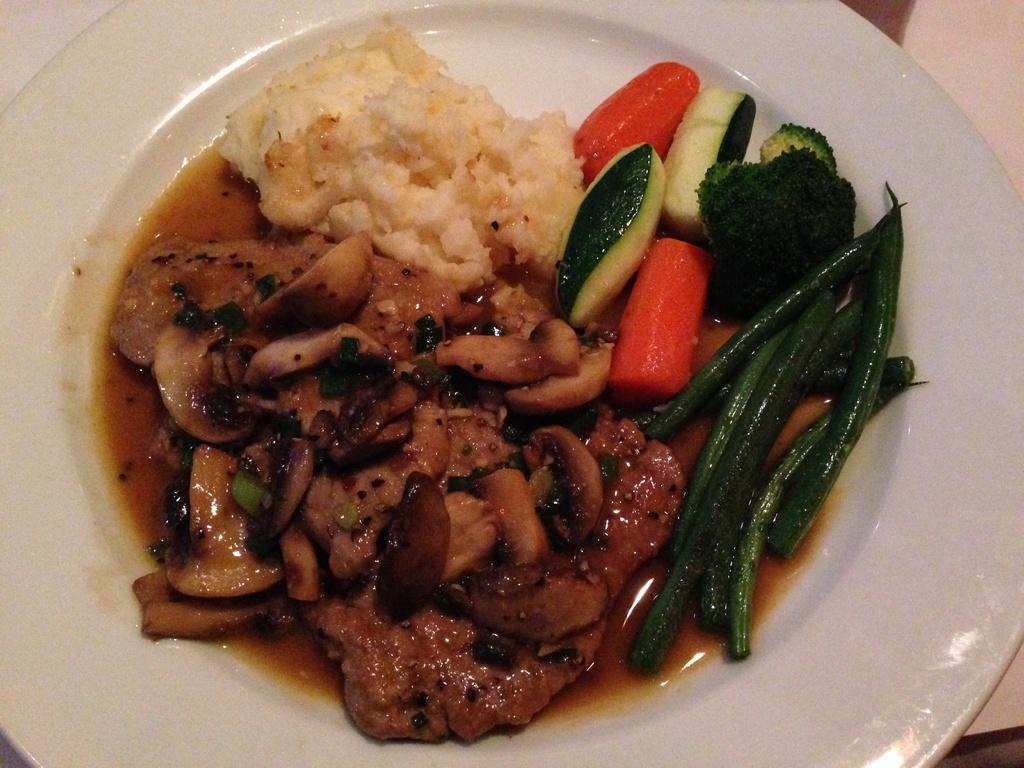What vegetables can be seen in the image? There is cabbage, cucumber, carrot, and other vegetables in the image. What type of grain is present in the image? There is rice in the image. How are the food items arranged in the image? The food items are on a white plate. What type of bike is visible in the image? There is no bike present in the image. What sign can be seen near the vegetables in the image? There is no sign present in the image. 